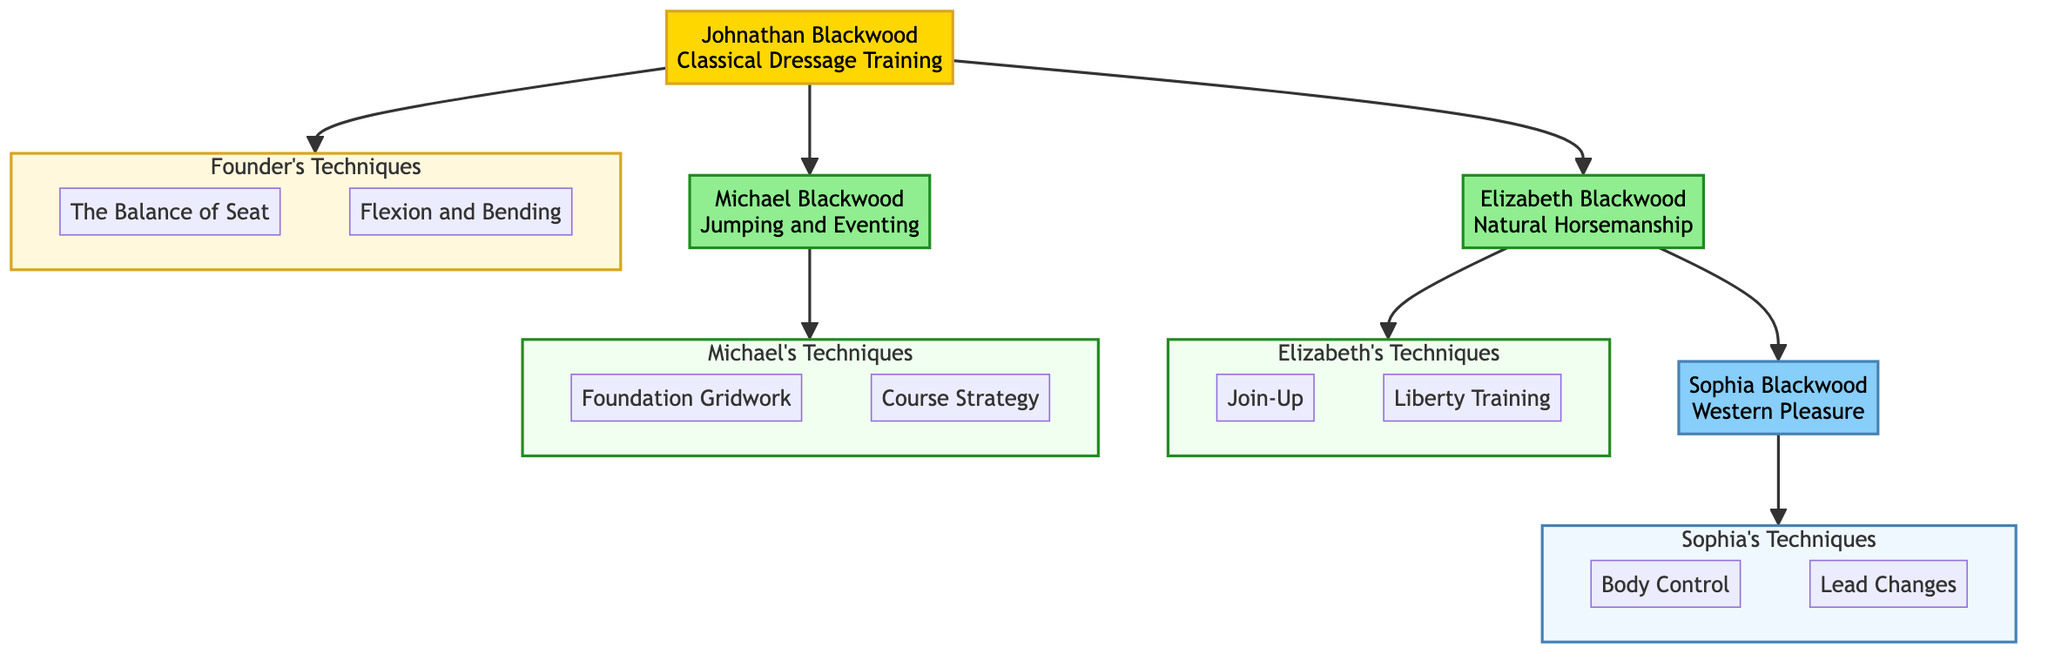What is Johnathan Blackwood's specialty? The diagram clearly labels Johnathan Blackwood as specializing in "Classical Dressage Training." This information is indicated directly in the node representing him.
Answer: Classical Dressage Training How many children does Johnathan Blackwood have? Counting the direct branches connected to Johnathan Blackwood, there are two children visible: Elizabeth Blackwood and Michael Blackwood. Therefore, the total number of children is two.
Answer: 2 What technique is taught by Elizabeth Blackwood? In the subtree under Elizabeth Blackwood, one of the techniques listed is "Join-Up." This is directly associated with her specialty in Natural Horsemanship.
Answer: Join-Up Which generation does Sophia Blackwood belong to? Sophia Blackwood is connected to Elizabeth Blackwood, who is described as Johnathan Blackwood's daughter. Thus, Sophia is one generation down and falls into the second generation of the family tree.
Answer: Second generation What relationship does Michael Blackwood have to Johnathan Blackwood? The diagram indicates that Michael Blackwood is labeled as the "Son" of Johnathan Blackwood, establishing a direct parent-child relationship.
Answer: Son How many techniques did Johnathan Blackwood pass down? Johnathan Blackwood has passed down two techniques as shown in his section of the diagram: "The Balance of Seat" and "Flexion and Bending." Counting these, the sum is two techniques.
Answer: 2 What specialty does Sophia Blackwood focus on? The diagram details Sophia Blackwood's specialty as "Western Pleasure." This is explicitly stated in the node corresponding to her expertise.
Answer: Western Pleasure Which technique of Michael Blackwood focuses on jumping? Among the techniques listed under Michael Blackwood, "Foundation Gridwork" is specifically about establishing rhythm, balance, and accuracy in jumping. This aligns with his focus area.
Answer: Foundation Gridwork How many techniques are associated with Elizabeth Blackwood? Elizabeth Blackwood is associated with two techniques: "Join-Up" and "Liberty Training." The diagram shows both in her section, leading to a count of two techniques.
Answer: 2 